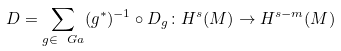Convert formula to latex. <formula><loc_0><loc_0><loc_500><loc_500>D = \sum _ { g \in \ G a } ( g ^ { * } ) ^ { - 1 } \circ D _ { g } \colon H ^ { s } ( M ) \to H ^ { s - m } ( M )</formula> 